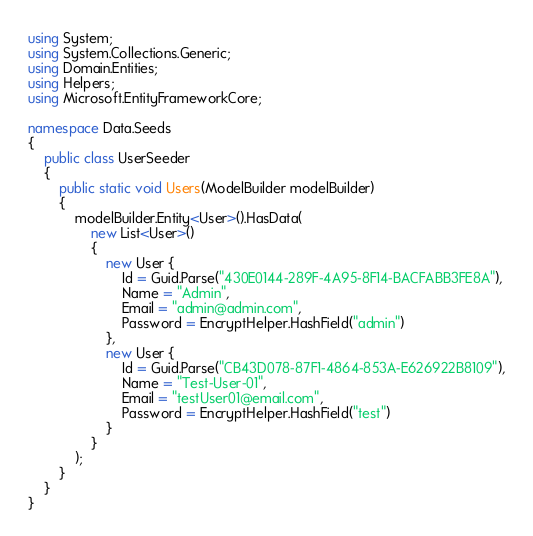<code> <loc_0><loc_0><loc_500><loc_500><_C#_>using System;
using System.Collections.Generic;
using Domain.Entities;
using Helpers;
using Microsoft.EntityFrameworkCore;

namespace Data.Seeds
{
    public class UserSeeder
    {
        public static void Users(ModelBuilder modelBuilder)
        {
            modelBuilder.Entity<User>().HasData(
                new List<User>()
                {
                    new User {
                        Id = Guid.Parse("430E0144-289F-4A95-8F14-BACFABB3FE8A"),
                        Name = "Admin",
                        Email = "admin@admin.com",
                        Password = EncryptHelper.HashField("admin")
                    },
                    new User {
                        Id = Guid.Parse("CB43D078-87F1-4864-853A-E626922B8109"),
                        Name = "Test-User-01",
                        Email = "testUser01@email.com",
                        Password = EncryptHelper.HashField("test")
                    }
                }
            );
        }
    }
}
</code> 